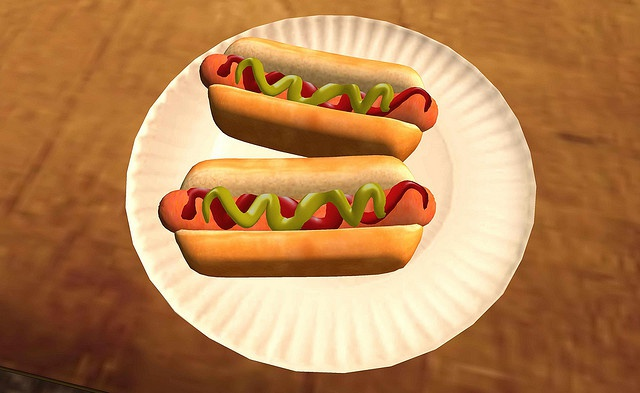Describe the objects in this image and their specific colors. I can see dining table in brown, beige, maroon, tan, and orange tones, hot dog in orange, maroon, and red tones, and hot dog in orange, maroon, red, and brown tones in this image. 